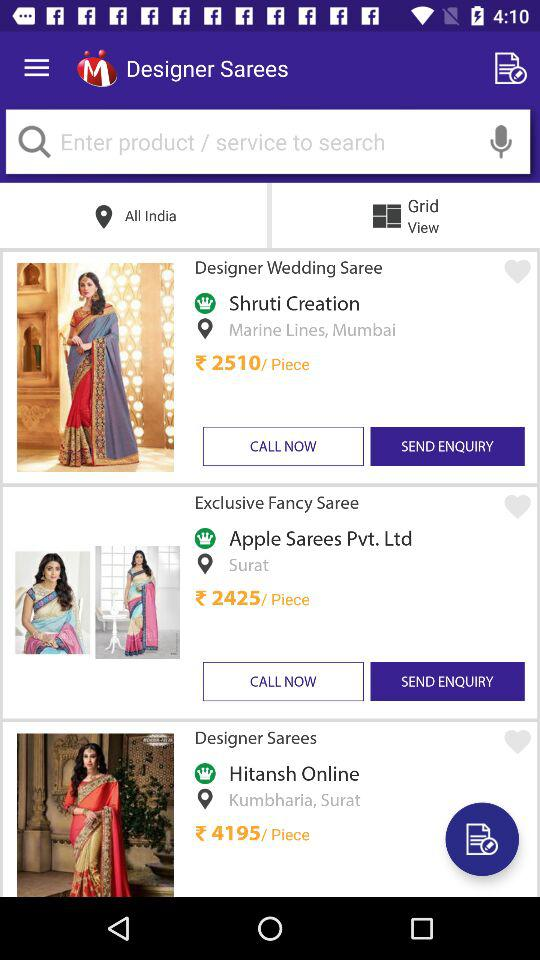How many items have a price higher than 2500?
Answer the question using a single word or phrase. 2 